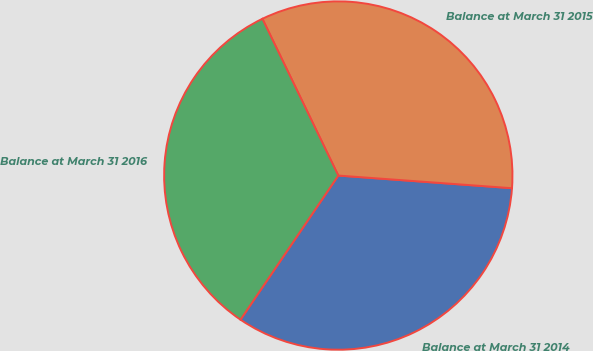<chart> <loc_0><loc_0><loc_500><loc_500><pie_chart><fcel>Balance at March 31 2014<fcel>Balance at March 31 2015<fcel>Balance at March 31 2016<nl><fcel>33.33%<fcel>33.33%<fcel>33.33%<nl></chart> 